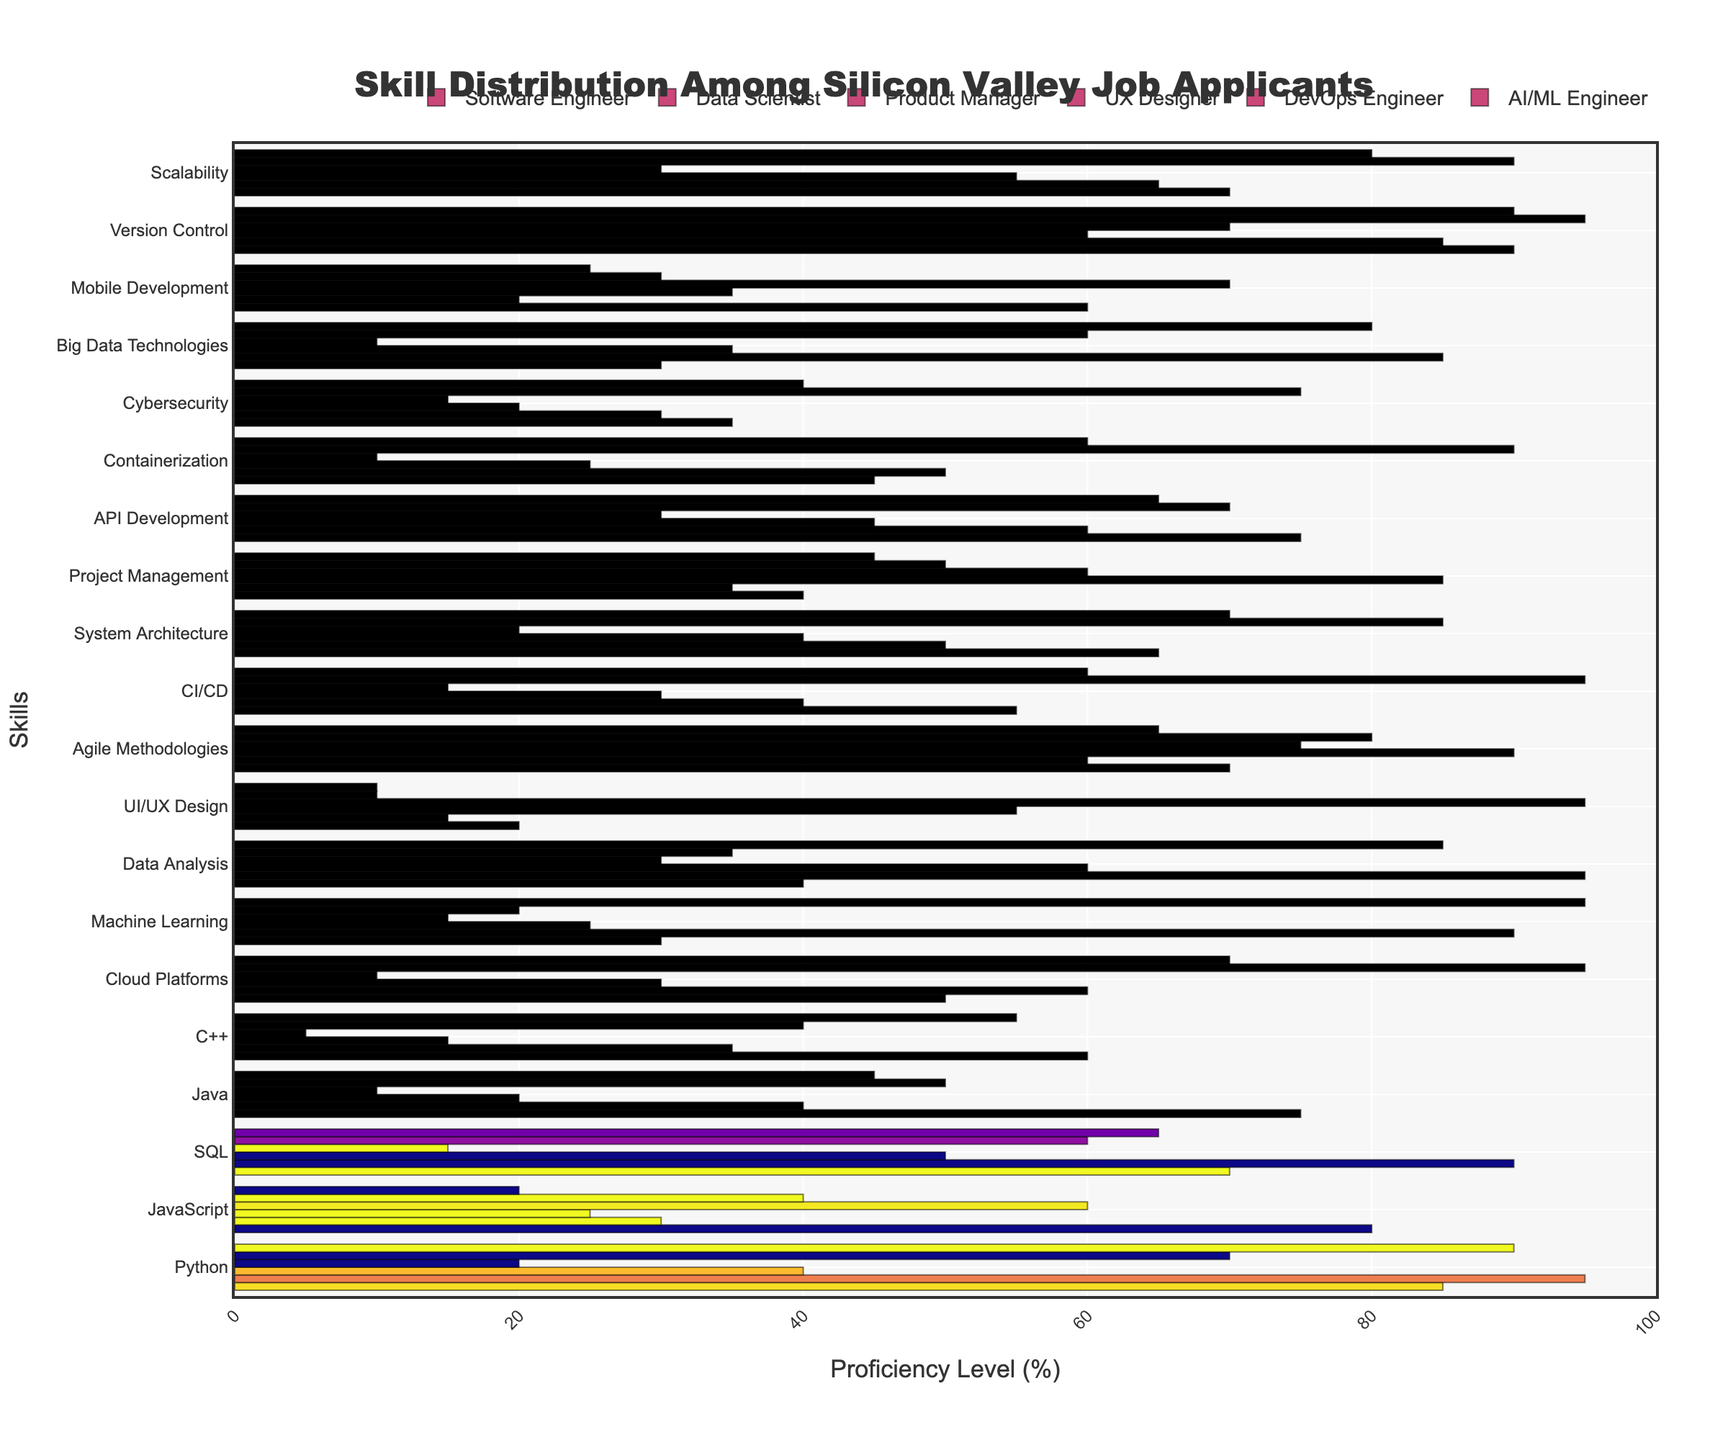Which role has the highest proficiency in Python? By visually inspecting the bar lengths representing Python proficiency for each role, we see that the "Data Scientist" role has the longest bar, indicating the highest proficiency.
Answer: Data Scientist Compare the proficiency levels in JavaScript between DevOps Engineers and UX Designers. Who has higher proficiency? The height of the bar for JavaScript under "DevOps Engineer" is greater than that under "UX Designer". This means DevOps Engineers have higher proficiency in JavaScript.
Answer: DevOps Engineers What’s the average proficiency level in Agile Methodologies across all roles? Add the proficiency values for Agile Methodologies for all roles: 70, 60, 90, 75, 80, 65. Sum these values to get 440. There are 6 roles, so the average is 440/6.
Answer: 73.3 Which skill has the highest proficiency among Product Managers? By examining the longest bar in the Product Manager category, we see that "Project Management" has the highest proficiency.
Answer: Project Management Are Data Analysts more proficient in SQL or Machine Learning? Compare the bar lengths for SQL and Machine Learning under "Data Scientist". The bar for SQL is longer, indicating higher proficiency in SQL.
Answer: SQL Which role has the lowest proficiency in UI/UX Design? By identifying the shortest bar in the UI/UX Design category across all roles, we see that "AI/ML Engineer" has the lowest proficiency.
Answer: AI/ML Engineer What is the total proficiency level in Cybersecurity across all roles? Sum up the proficiency values for Cybersecurity across all roles: 35, 30, 20, 15, 75, and 40. The total is 215.
Answer: 215 Which role has a greater difference in proficiency levels between Machine Learning and Data Analysis? Compare Software Engineer and AI/ML Engineer. Calculate the difference for Software Engineers (90 - 40 = 50) and AI/ML Engineers (95 - 85 = 10). The greater difference is for "Software Engineer".
Answer: Software Engineer How does the proficiency in Version Control compare between Software Engineers and UX Designers? Look at the bars for Version Control for both roles. The "Software Engineer" bar is longer than the "UX Designer" bar, indicating higher proficiency for Software Engineers.
Answer: Software Engineers 